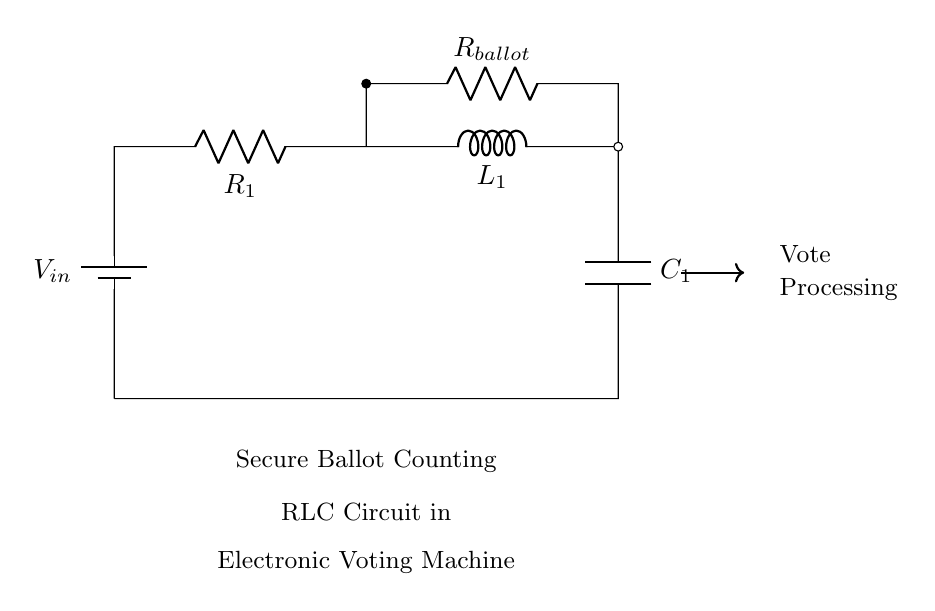What is the voltage source in this circuit? The voltage source is labeled as V_in, which provides the input voltage for the circuit.
Answer: V_in What components are used in the circuit? The components in the circuit are a resistor labeled R_1, an inductor labeled L_1, a capacitor labeled C_1, and an additional resistor labeled R_ballot.
Answer: R_1, L_1, C_1, R_ballot What does the RLC circuit in this diagram represent? The RLC circuit represents a secure ballot counting system within an electronic voting machine.
Answer: Secure ballot counting What is the function of R_ballot in the circuit? R_ballot is connected in parallel to the other components, potentially relating to the ballot counting process, impacting the measurement of current associated with voting.
Answer: Ballot counting How does the inductor L_1 affect the circuit behavior? The inductor L_1 impacts the circuit's response to changing currents, storing energy in a magnetic field, which can influence the stability and timing of the vote processing.
Answer: Energy storage What is the significance of the capacitor C_1 in this context? The capacitor C_1 stores electrical energy and can help filter voltage fluctuations, providing stability in the voltage readings critical for accurate ballot counting.
Answer: Voltage stabilization What is the role of the connections in this circuit? The connections establish the flow of electrical current between all components, ensuring that the entire RLC circuit works together to properly process and count ballots.
Answer: Establish current flow 